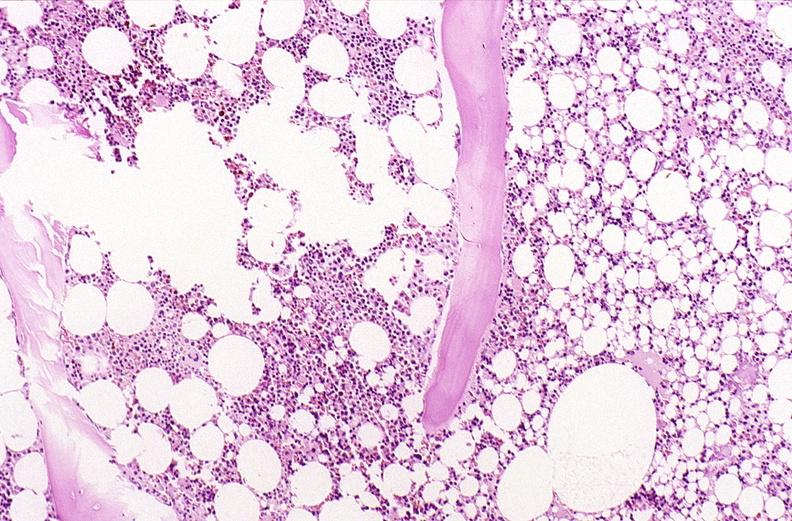what is present?
Answer the question using a single word or phrase. Musculoskeletal 